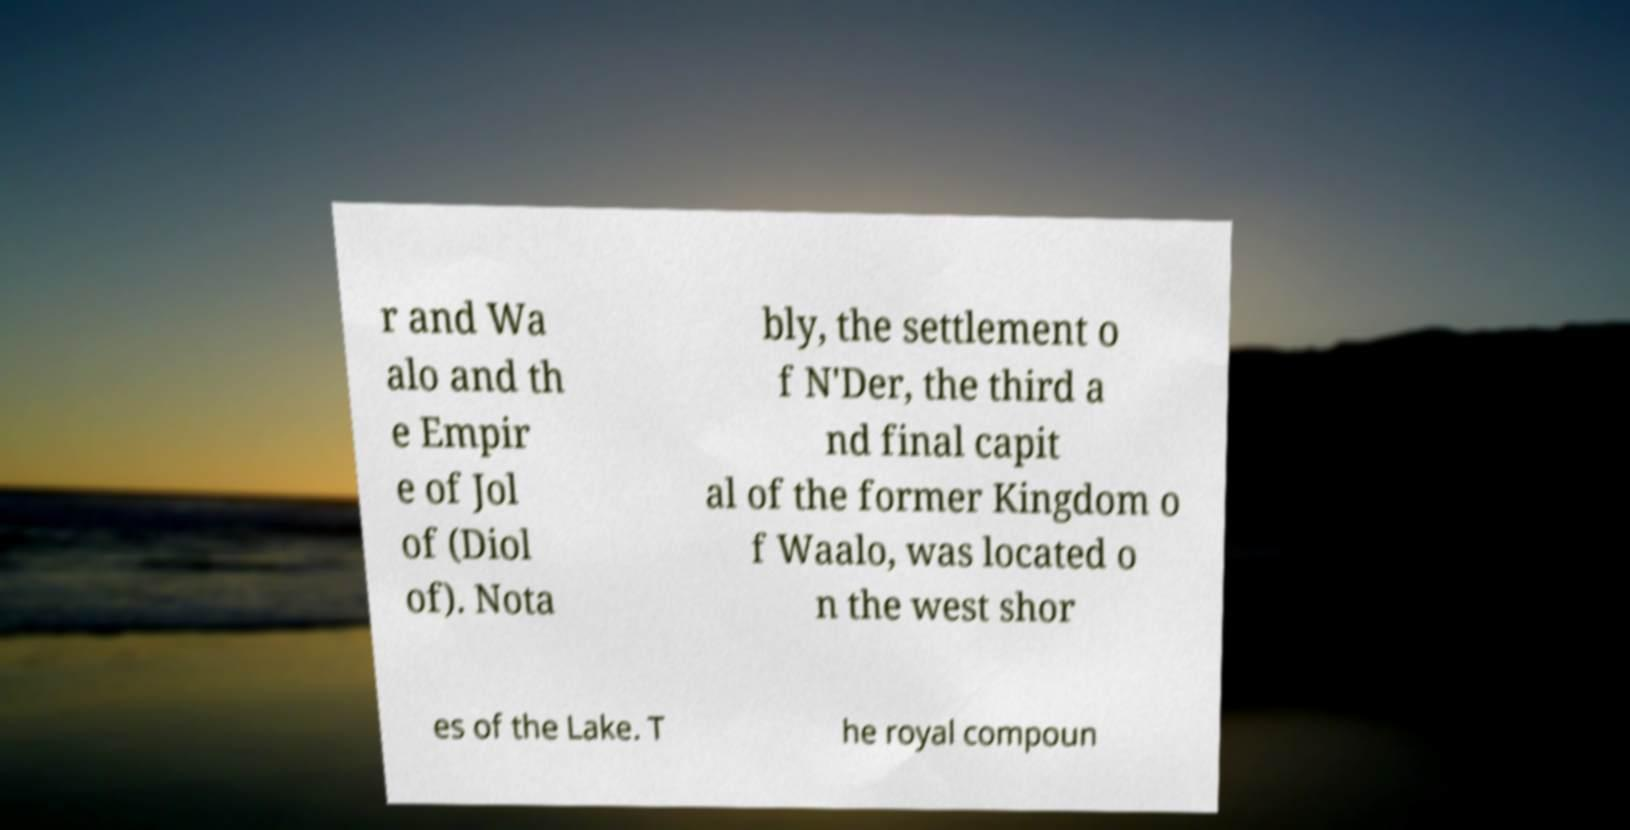Please identify and transcribe the text found in this image. r and Wa alo and th e Empir e of Jol of (Diol of). Nota bly, the settlement o f N'Der, the third a nd final capit al of the former Kingdom o f Waalo, was located o n the west shor es of the Lake. T he royal compoun 